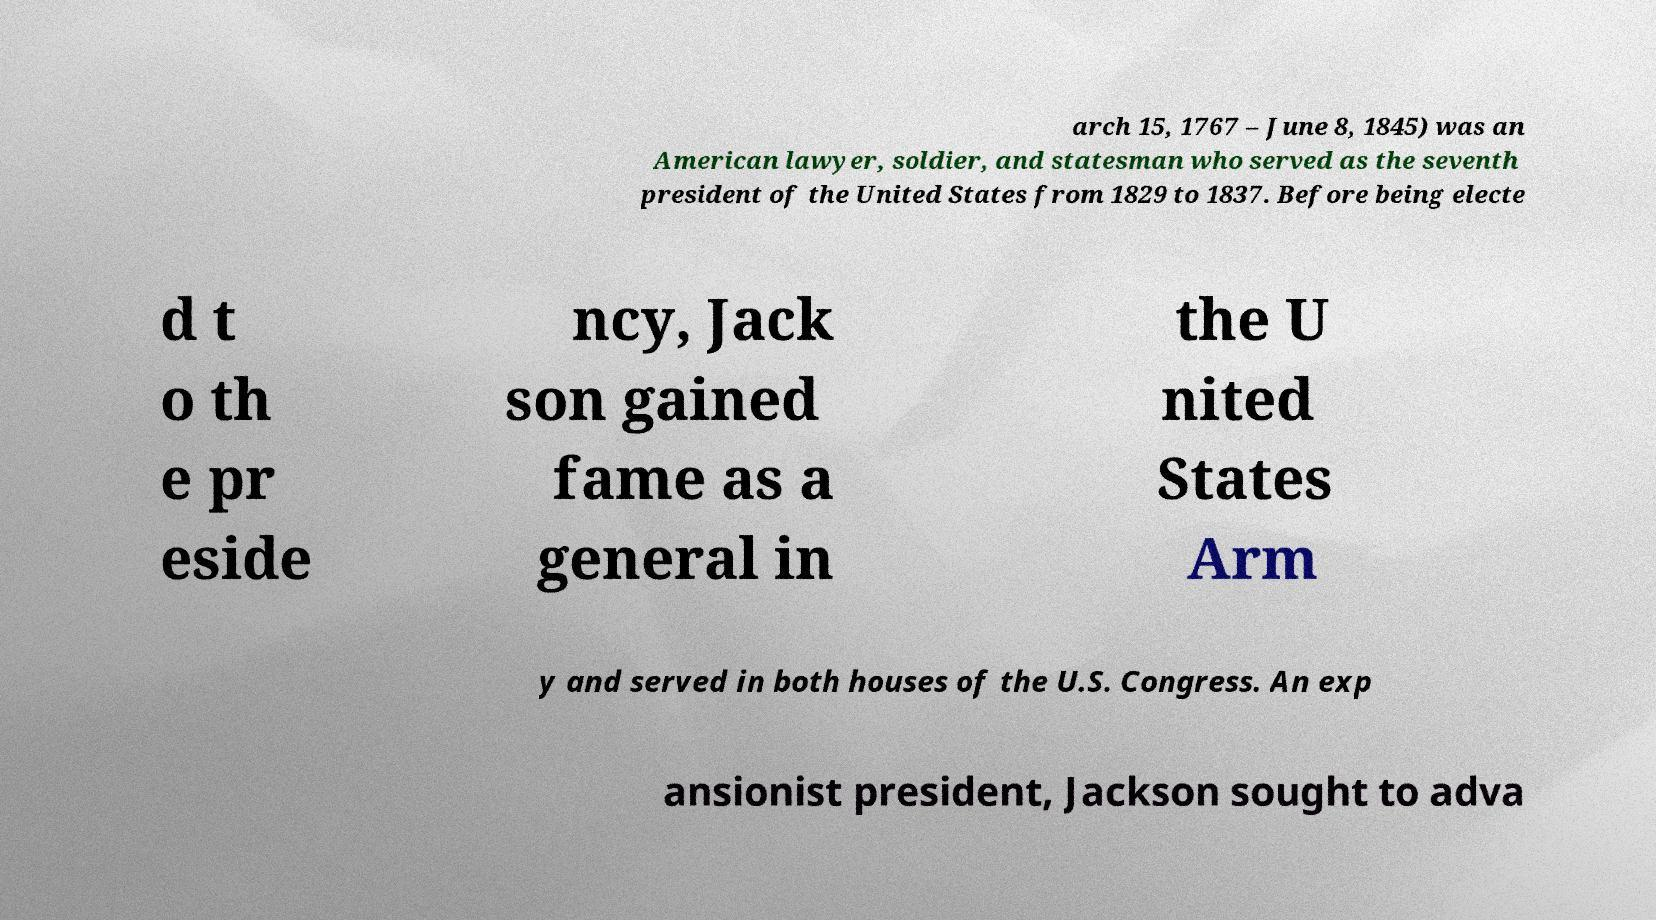I need the written content from this picture converted into text. Can you do that? arch 15, 1767 – June 8, 1845) was an American lawyer, soldier, and statesman who served as the seventh president of the United States from 1829 to 1837. Before being electe d t o th e pr eside ncy, Jack son gained fame as a general in the U nited States Arm y and served in both houses of the U.S. Congress. An exp ansionist president, Jackson sought to adva 